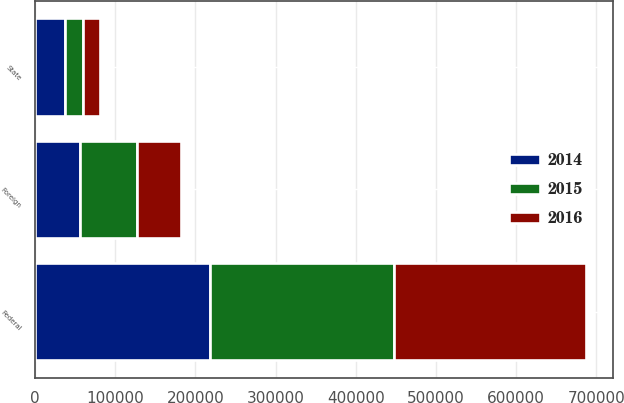Convert chart. <chart><loc_0><loc_0><loc_500><loc_500><stacked_bar_chart><ecel><fcel>Federal<fcel>State<fcel>Foreign<nl><fcel>2016<fcel>239217<fcel>21779<fcel>54937<nl><fcel>2015<fcel>229224<fcel>22041<fcel>71507<nl><fcel>2014<fcel>218302<fcel>37155<fcel>56107<nl></chart> 